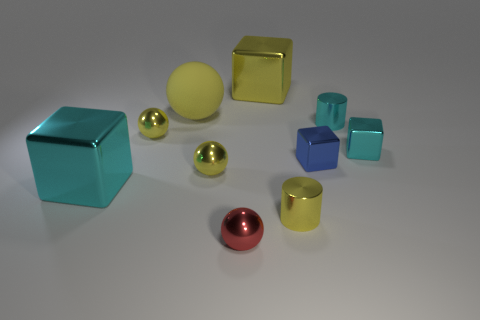Subtract all yellow cubes. How many yellow spheres are left? 3 Subtract 1 balls. How many balls are left? 3 Subtract all blocks. How many objects are left? 6 Subtract 1 red spheres. How many objects are left? 9 Subtract all purple metal cylinders. Subtract all matte objects. How many objects are left? 9 Add 3 blue objects. How many blue objects are left? 4 Add 10 big yellow rubber cylinders. How many big yellow rubber cylinders exist? 10 